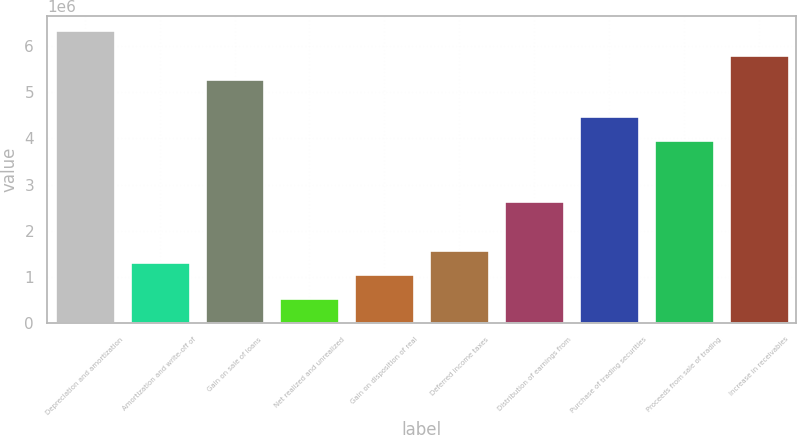<chart> <loc_0><loc_0><loc_500><loc_500><bar_chart><fcel>Depreciation and amortization<fcel>Amortization and write-off of<fcel>Gain on sale of loans<fcel>Net realized and unrealized<fcel>Gain on disposition of real<fcel>Deferred income taxes<fcel>Distribution of earnings from<fcel>Purchase of trading securities<fcel>Proceeds from sale of trading<fcel>Increase in receivables<nl><fcel>6.34219e+06<fcel>1.32254e+06<fcel>5.28542e+06<fcel>529961<fcel>1.05835e+06<fcel>1.58673e+06<fcel>2.6435e+06<fcel>4.49285e+06<fcel>3.96446e+06<fcel>5.81381e+06<nl></chart> 